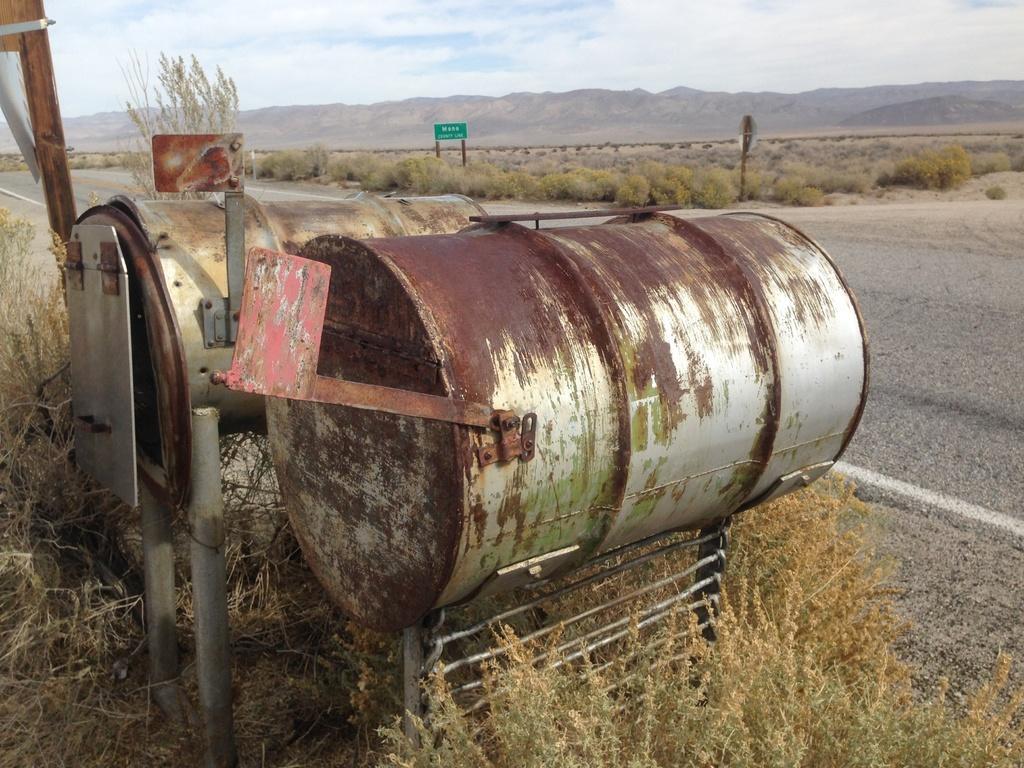Could you give a brief overview of what you see in this image? In this picture I can see couple of metal barrels and a board with some text and I can see plants, tree and I can see a hill and a blue cloudy sky. 